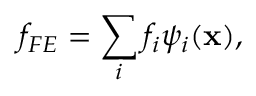<formula> <loc_0><loc_0><loc_500><loc_500>f _ { F E } = \sum _ { i } f _ { i } \psi _ { i } ( x ) ,</formula> 